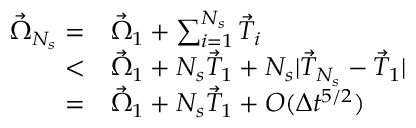Convert formula to latex. <formula><loc_0><loc_0><loc_500><loc_500>\begin{array} { r l } { \vec { \Omega } _ { N _ { s } } = } & { \vec { \Omega } _ { 1 } + \sum _ { i = 1 } ^ { N _ { s } } \vec { T } _ { i } } \\ { < } & { \vec { \Omega } _ { 1 } + N _ { s } \vec { T } _ { 1 } + N _ { s } | \vec { T } _ { N _ { s } } - \vec { T } _ { 1 } | } \\ { = } & { \vec { \Omega } _ { 1 } + N _ { s } \vec { T } _ { 1 } + O ( \Delta t ^ { 5 / 2 } ) } \end{array}</formula> 